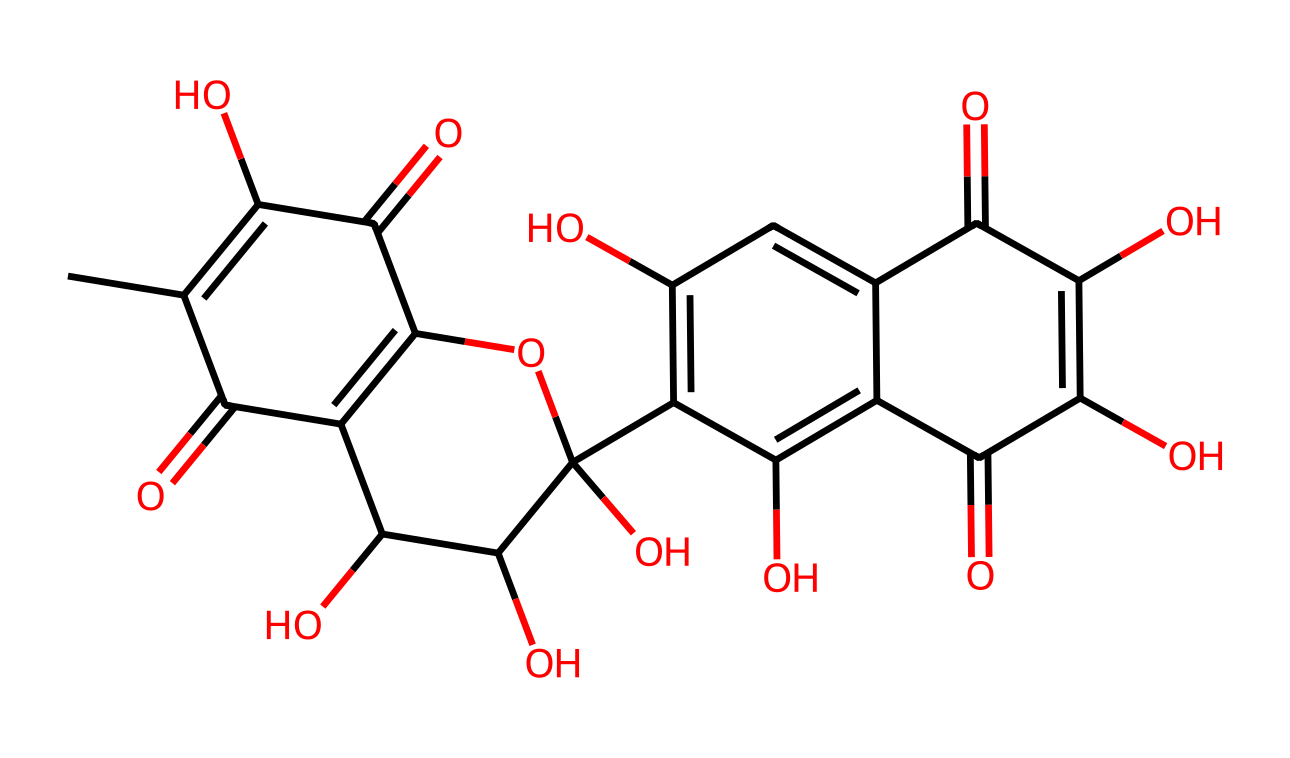What is the total number of carbon atoms in this chemical structure? To determine the total number of carbon atoms, we can analyze the SMILES representation. Each "C" represents a carbon atom, and by counting them, we find there are 20 carbon atoms in total.
Answer: 20 How many hydroxyl (–OH) groups are present in the structure? The presence of hydroxyl groups is indicated by "O" that follows a carbon in the structure. By identifying each occurrence of "O" that is bonded to a carbon and is part of a phenolic or alcohol group, we find there are 6 hydroxyl groups.
Answer: 6 What type of chemical is this, based on its structure? The large number of hydroxyl groups in the structure suggests that this compound is likely a type of flavonoid, which often includes multiple hydroxyl groups and has aromatic rings.
Answer: flavonoid What kind of functional groups can be identified in this chemical? The structure reveals several functional groups, including hydroxyl (–OH) groups, carbonyl (C=O) groups from the ketone and aldehyde moieties, and carboxylic acid (–COOH) groups. This combination suggests a highly functional organic molecule.
Answer: hydroxyl, carbonyl, carboxylic acid Which part of the chemical structure is responsible for its color? The conjugated double bonds present in the aromatic rings contribute to the molecular color, due to their ability to absorb specific wavelengths of light. This is characteristic of many dyes, including those used in cosmetics.
Answer: conjugated double bonds 